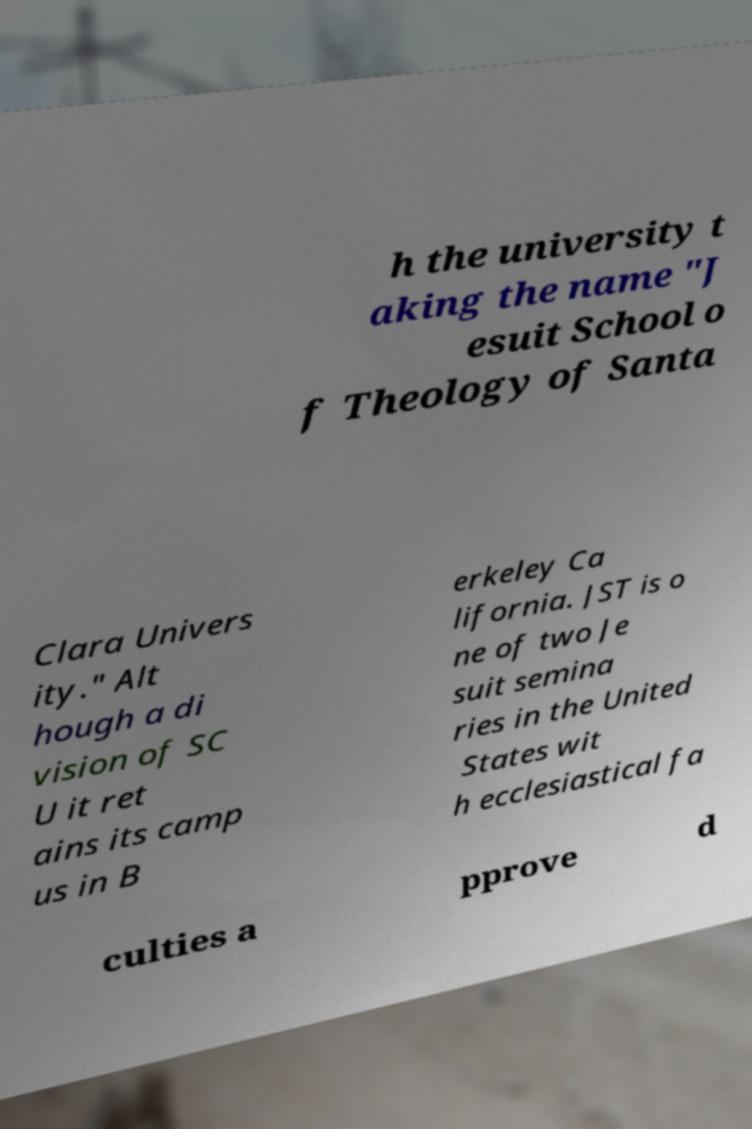What messages or text are displayed in this image? I need them in a readable, typed format. h the university t aking the name "J esuit School o f Theology of Santa Clara Univers ity." Alt hough a di vision of SC U it ret ains its camp us in B erkeley Ca lifornia. JST is o ne of two Je suit semina ries in the United States wit h ecclesiastical fa culties a pprove d 